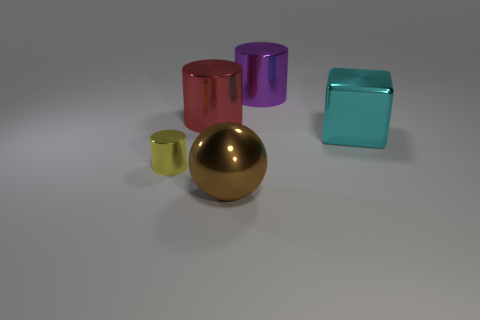Is there anything else that has the same size as the yellow metal cylinder?
Provide a succinct answer. No. Are there any large red metallic things of the same shape as the tiny yellow object?
Offer a terse response. Yes. What number of brown things are either big spheres or cubes?
Your answer should be compact. 1. Is there a purple metal cylinder that has the same size as the block?
Keep it short and to the point. Yes. How many small metal cylinders are there?
Ensure brevity in your answer.  1. How many tiny things are purple metal blocks or cylinders?
Ensure brevity in your answer.  1. The large cylinder to the right of the brown ball that is on the left side of the metal cylinder right of the brown metallic object is what color?
Give a very brief answer. Purple. How many other objects are there of the same color as the large sphere?
Make the answer very short. 0. What number of rubber objects are tiny yellow cylinders or purple cylinders?
Keep it short and to the point. 0. There is a large metal thing that is on the left side of the big sphere; is its color the same as the cylinder that is in front of the big metallic cube?
Your answer should be very brief. No. 